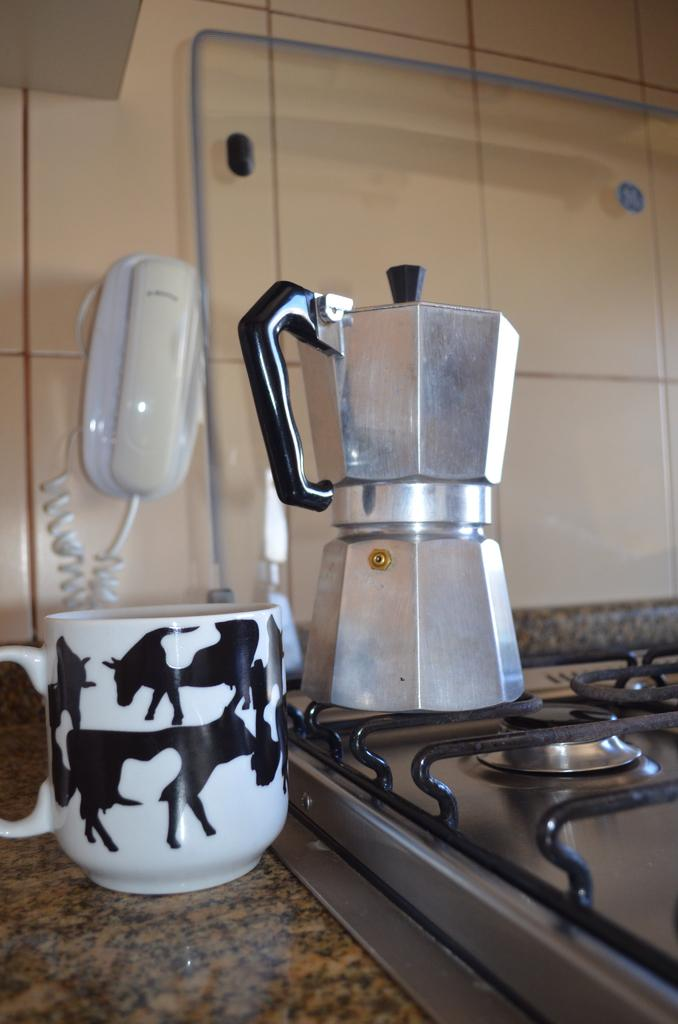What appliance is located at the bottom of the image? There is a stove at the bottom of the image. What type of container is visible in the image? There is a cup in the image. What kitchen appliance can be seen in the image? There is a mixer in the image. What is the background of the image made of? There is a wall at the top of the image. What communication device is attached to the wall? There is a landline phone on the wall. Is there any blood visible on the stove in the image? No, there is no blood visible on the stove in the image. What type of bell can be heard ringing in the image? There is no bell present in the image, and therefore no sound can be heard. 